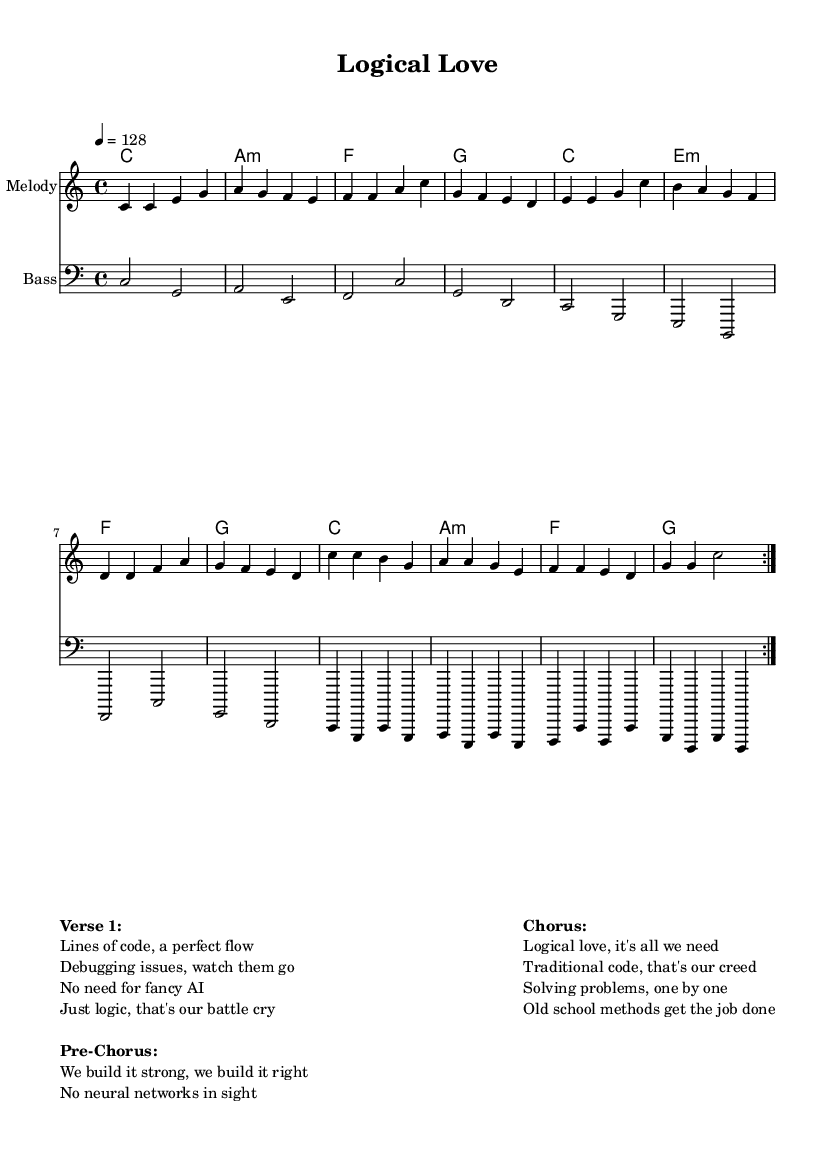What is the key signature of this music? The key signature is C major, which has no sharps or flats.
Answer: C major What is the time signature of this piece? The time signature is indicated at the beginning and shows that each measure is divided into four beats, with a quarter note receiving one beat.
Answer: 4/4 What is the tempo marking for this music? The tempo marking of 4 = 128 indicates the speed of the piece, specifically that there are 128 beats per minute.
Answer: 128 How many times is the melody repeated in the first section? The melody is repeated two times as indicated by the "repeat volta" markings in the music.
Answer: 2 What chord follows the A minor chord in the first progression? The progression shows an A minor chord followed by an F major chord in the harmonies.
Answer: F What is the main theme expressed in the chorus of this song? The chorus emphasizes traditional coding methods as a solution, stating "Logical love, it's all we need" and "Old school methods get the job done."
Answer: Logical love Which section of the song focuses on building strong foundations without AI? The pre-chorus centers on this theme by stating "We build it strong, we build it right" with a clear stance against using neural networks.
Answer: Pre-Chorus 